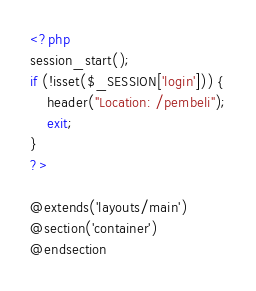Convert code to text. <code><loc_0><loc_0><loc_500><loc_500><_PHP_><?php
session_start();
if (!isset($_SESSION['login'])) {
    header("Location: /pembeli");
    exit;
}
?>

@extends('layouts/main')
@section('container')
@endsection</code> 